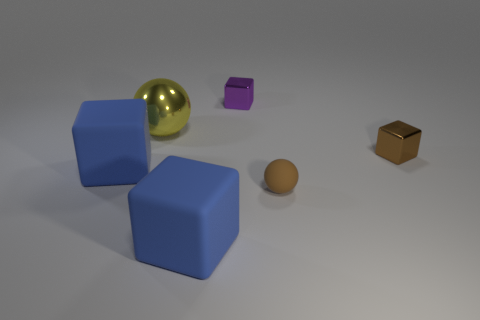What number of things are either blue objects or blue rubber blocks left of the big yellow sphere?
Your answer should be compact. 2. The tiny rubber thing is what shape?
Make the answer very short. Sphere. What shape is the metallic object that is on the right side of the tiny thing that is on the left side of the tiny brown rubber ball?
Keep it short and to the point. Cube. There is a small thing that is made of the same material as the tiny purple cube; what color is it?
Keep it short and to the point. Brown. Do the big thing that is to the left of the big metallic thing and the big thing that is on the right side of the large metallic object have the same color?
Provide a short and direct response. Yes. Are there more big rubber cubes on the right side of the big yellow thing than tiny purple metal cubes behind the tiny purple thing?
Your answer should be compact. Yes. There is another small object that is the same shape as the tiny purple metallic object; what color is it?
Your answer should be very brief. Brown. Do the brown matte thing and the large blue thing that is in front of the rubber ball have the same shape?
Your answer should be compact. No. What number of other things are made of the same material as the tiny purple block?
Ensure brevity in your answer.  2. Do the big ball and the shiny cube that is in front of the purple thing have the same color?
Your response must be concise. No. 